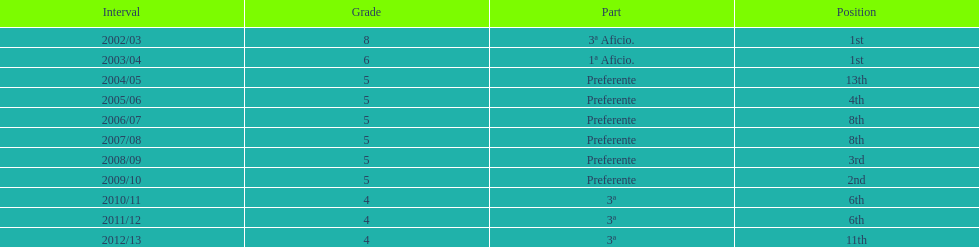How many seasons did internacional de madrid cf play in the preferente division? 6. 